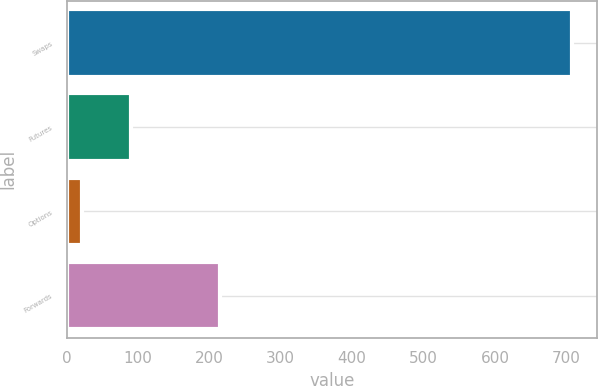Convert chart to OTSL. <chart><loc_0><loc_0><loc_500><loc_500><bar_chart><fcel>Swaps<fcel>Futures<fcel>Options<fcel>Forwards<nl><fcel>708<fcel>89.7<fcel>21<fcel>215<nl></chart> 